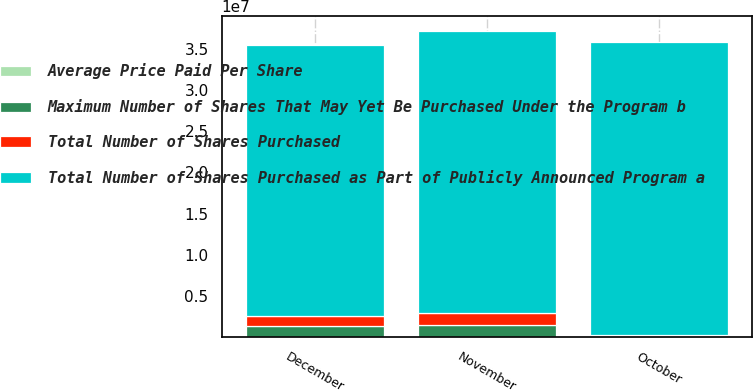<chart> <loc_0><loc_0><loc_500><loc_500><stacked_bar_chart><ecel><fcel>October<fcel>November<fcel>December<nl><fcel>Maximum Number of Shares That May Yet Be Purchased Under the Program b<fcel>127100<fcel>1.5043e+06<fcel>1.3259e+06<nl><fcel>Average Price Paid Per Share<fcel>108.58<fcel>109.07<fcel>108.78<nl><fcel>Total Number of Shares Purchased<fcel>127100<fcel>1.5043e+06<fcel>1.3259e+06<nl><fcel>Total Number of Shares Purchased as Part of Publicly Announced Program a<fcel>3.55731e+07<fcel>3.40688e+07<fcel>3.27429e+07<nl></chart> 